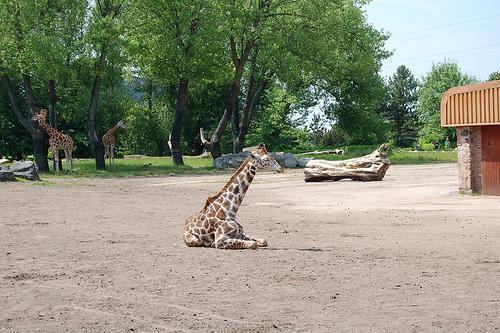How many giraffes are sitting?
Give a very brief answer. 1. 